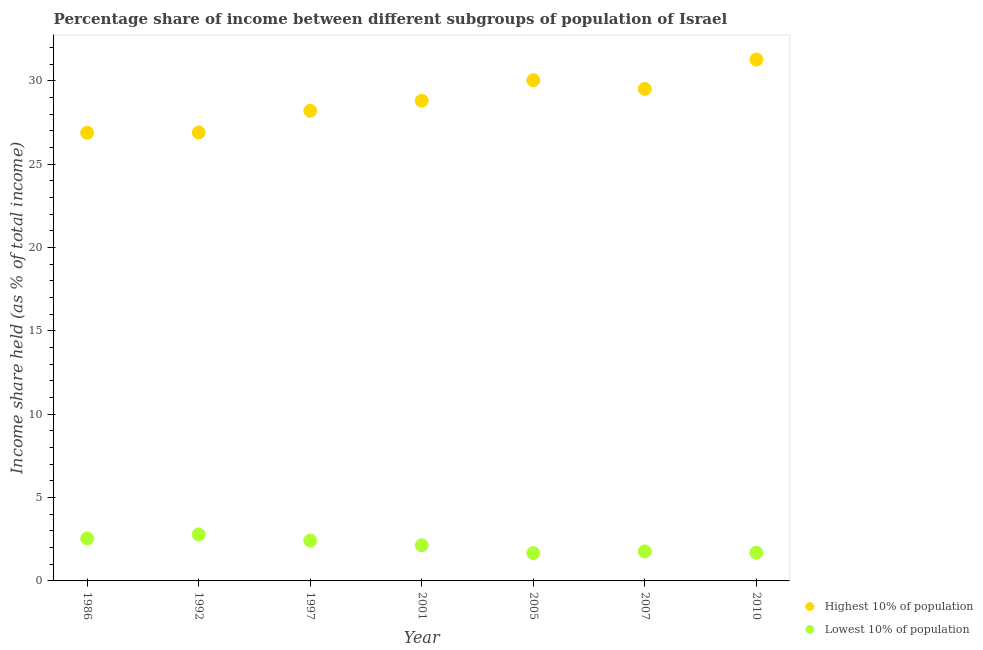Is the number of dotlines equal to the number of legend labels?
Keep it short and to the point. Yes. What is the income share held by lowest 10% of the population in 2001?
Your answer should be very brief. 2.14. Across all years, what is the maximum income share held by highest 10% of the population?
Your answer should be very brief. 31.27. Across all years, what is the minimum income share held by highest 10% of the population?
Make the answer very short. 26.88. In which year was the income share held by lowest 10% of the population maximum?
Your answer should be compact. 1992. What is the total income share held by highest 10% of the population in the graph?
Offer a terse response. 201.59. What is the difference between the income share held by lowest 10% of the population in 1997 and that in 2001?
Offer a terse response. 0.28. What is the difference between the income share held by lowest 10% of the population in 2010 and the income share held by highest 10% of the population in 1986?
Provide a short and direct response. -25.19. What is the average income share held by lowest 10% of the population per year?
Your response must be concise. 2.15. In the year 1997, what is the difference between the income share held by highest 10% of the population and income share held by lowest 10% of the population?
Offer a very short reply. 25.78. In how many years, is the income share held by lowest 10% of the population greater than 19 %?
Keep it short and to the point. 0. What is the ratio of the income share held by highest 10% of the population in 1986 to that in 2007?
Ensure brevity in your answer.  0.91. Is the income share held by lowest 10% of the population in 1992 less than that in 2007?
Ensure brevity in your answer.  No. What is the difference between the highest and the second highest income share held by lowest 10% of the population?
Your response must be concise. 0.24. What is the difference between the highest and the lowest income share held by highest 10% of the population?
Keep it short and to the point. 4.39. In how many years, is the income share held by lowest 10% of the population greater than the average income share held by lowest 10% of the population taken over all years?
Make the answer very short. 3. Is the income share held by highest 10% of the population strictly greater than the income share held by lowest 10% of the population over the years?
Keep it short and to the point. Yes. How many years are there in the graph?
Your answer should be compact. 7. What is the difference between two consecutive major ticks on the Y-axis?
Offer a very short reply. 5. Are the values on the major ticks of Y-axis written in scientific E-notation?
Give a very brief answer. No. Does the graph contain grids?
Give a very brief answer. No. Where does the legend appear in the graph?
Your answer should be very brief. Bottom right. How are the legend labels stacked?
Offer a terse response. Vertical. What is the title of the graph?
Provide a succinct answer. Percentage share of income between different subgroups of population of Israel. What is the label or title of the X-axis?
Offer a terse response. Year. What is the label or title of the Y-axis?
Provide a short and direct response. Income share held (as % of total income). What is the Income share held (as % of total income) of Highest 10% of population in 1986?
Offer a very short reply. 26.88. What is the Income share held (as % of total income) in Lowest 10% of population in 1986?
Provide a short and direct response. 2.55. What is the Income share held (as % of total income) in Highest 10% of population in 1992?
Your answer should be very brief. 26.9. What is the Income share held (as % of total income) in Lowest 10% of population in 1992?
Ensure brevity in your answer.  2.79. What is the Income share held (as % of total income) in Highest 10% of population in 1997?
Your response must be concise. 28.2. What is the Income share held (as % of total income) of Lowest 10% of population in 1997?
Your response must be concise. 2.42. What is the Income share held (as % of total income) in Highest 10% of population in 2001?
Your answer should be compact. 28.8. What is the Income share held (as % of total income) of Lowest 10% of population in 2001?
Offer a very short reply. 2.14. What is the Income share held (as % of total income) in Highest 10% of population in 2005?
Provide a succinct answer. 30.03. What is the Income share held (as % of total income) in Lowest 10% of population in 2005?
Provide a succinct answer. 1.67. What is the Income share held (as % of total income) in Highest 10% of population in 2007?
Offer a terse response. 29.51. What is the Income share held (as % of total income) of Lowest 10% of population in 2007?
Your response must be concise. 1.77. What is the Income share held (as % of total income) in Highest 10% of population in 2010?
Provide a succinct answer. 31.27. What is the Income share held (as % of total income) of Lowest 10% of population in 2010?
Give a very brief answer. 1.69. Across all years, what is the maximum Income share held (as % of total income) of Highest 10% of population?
Your response must be concise. 31.27. Across all years, what is the maximum Income share held (as % of total income) in Lowest 10% of population?
Make the answer very short. 2.79. Across all years, what is the minimum Income share held (as % of total income) of Highest 10% of population?
Make the answer very short. 26.88. Across all years, what is the minimum Income share held (as % of total income) of Lowest 10% of population?
Provide a short and direct response. 1.67. What is the total Income share held (as % of total income) of Highest 10% of population in the graph?
Offer a terse response. 201.59. What is the total Income share held (as % of total income) in Lowest 10% of population in the graph?
Keep it short and to the point. 15.03. What is the difference between the Income share held (as % of total income) in Highest 10% of population in 1986 and that in 1992?
Your answer should be very brief. -0.02. What is the difference between the Income share held (as % of total income) in Lowest 10% of population in 1986 and that in 1992?
Ensure brevity in your answer.  -0.24. What is the difference between the Income share held (as % of total income) in Highest 10% of population in 1986 and that in 1997?
Offer a very short reply. -1.32. What is the difference between the Income share held (as % of total income) in Lowest 10% of population in 1986 and that in 1997?
Provide a short and direct response. 0.13. What is the difference between the Income share held (as % of total income) of Highest 10% of population in 1986 and that in 2001?
Make the answer very short. -1.92. What is the difference between the Income share held (as % of total income) in Lowest 10% of population in 1986 and that in 2001?
Your answer should be very brief. 0.41. What is the difference between the Income share held (as % of total income) of Highest 10% of population in 1986 and that in 2005?
Keep it short and to the point. -3.15. What is the difference between the Income share held (as % of total income) of Lowest 10% of population in 1986 and that in 2005?
Keep it short and to the point. 0.88. What is the difference between the Income share held (as % of total income) in Highest 10% of population in 1986 and that in 2007?
Give a very brief answer. -2.63. What is the difference between the Income share held (as % of total income) of Lowest 10% of population in 1986 and that in 2007?
Offer a very short reply. 0.78. What is the difference between the Income share held (as % of total income) in Highest 10% of population in 1986 and that in 2010?
Give a very brief answer. -4.39. What is the difference between the Income share held (as % of total income) in Lowest 10% of population in 1986 and that in 2010?
Your answer should be very brief. 0.86. What is the difference between the Income share held (as % of total income) of Highest 10% of population in 1992 and that in 1997?
Your answer should be compact. -1.3. What is the difference between the Income share held (as % of total income) of Lowest 10% of population in 1992 and that in 1997?
Your answer should be very brief. 0.37. What is the difference between the Income share held (as % of total income) in Lowest 10% of population in 1992 and that in 2001?
Offer a very short reply. 0.65. What is the difference between the Income share held (as % of total income) in Highest 10% of population in 1992 and that in 2005?
Keep it short and to the point. -3.13. What is the difference between the Income share held (as % of total income) in Lowest 10% of population in 1992 and that in 2005?
Your answer should be compact. 1.12. What is the difference between the Income share held (as % of total income) of Highest 10% of population in 1992 and that in 2007?
Make the answer very short. -2.61. What is the difference between the Income share held (as % of total income) in Lowest 10% of population in 1992 and that in 2007?
Your response must be concise. 1.02. What is the difference between the Income share held (as % of total income) in Highest 10% of population in 1992 and that in 2010?
Give a very brief answer. -4.37. What is the difference between the Income share held (as % of total income) of Highest 10% of population in 1997 and that in 2001?
Ensure brevity in your answer.  -0.6. What is the difference between the Income share held (as % of total income) of Lowest 10% of population in 1997 and that in 2001?
Give a very brief answer. 0.28. What is the difference between the Income share held (as % of total income) of Highest 10% of population in 1997 and that in 2005?
Keep it short and to the point. -1.83. What is the difference between the Income share held (as % of total income) in Highest 10% of population in 1997 and that in 2007?
Your response must be concise. -1.31. What is the difference between the Income share held (as % of total income) of Lowest 10% of population in 1997 and that in 2007?
Provide a succinct answer. 0.65. What is the difference between the Income share held (as % of total income) of Highest 10% of population in 1997 and that in 2010?
Provide a succinct answer. -3.07. What is the difference between the Income share held (as % of total income) of Lowest 10% of population in 1997 and that in 2010?
Ensure brevity in your answer.  0.73. What is the difference between the Income share held (as % of total income) in Highest 10% of population in 2001 and that in 2005?
Ensure brevity in your answer.  -1.23. What is the difference between the Income share held (as % of total income) in Lowest 10% of population in 2001 and that in 2005?
Keep it short and to the point. 0.47. What is the difference between the Income share held (as % of total income) of Highest 10% of population in 2001 and that in 2007?
Provide a succinct answer. -0.71. What is the difference between the Income share held (as % of total income) of Lowest 10% of population in 2001 and that in 2007?
Your answer should be compact. 0.37. What is the difference between the Income share held (as % of total income) of Highest 10% of population in 2001 and that in 2010?
Ensure brevity in your answer.  -2.47. What is the difference between the Income share held (as % of total income) of Lowest 10% of population in 2001 and that in 2010?
Keep it short and to the point. 0.45. What is the difference between the Income share held (as % of total income) of Highest 10% of population in 2005 and that in 2007?
Keep it short and to the point. 0.52. What is the difference between the Income share held (as % of total income) in Lowest 10% of population in 2005 and that in 2007?
Provide a succinct answer. -0.1. What is the difference between the Income share held (as % of total income) of Highest 10% of population in 2005 and that in 2010?
Your response must be concise. -1.24. What is the difference between the Income share held (as % of total income) of Lowest 10% of population in 2005 and that in 2010?
Provide a succinct answer. -0.02. What is the difference between the Income share held (as % of total income) in Highest 10% of population in 2007 and that in 2010?
Offer a very short reply. -1.76. What is the difference between the Income share held (as % of total income) in Highest 10% of population in 1986 and the Income share held (as % of total income) in Lowest 10% of population in 1992?
Your answer should be very brief. 24.09. What is the difference between the Income share held (as % of total income) in Highest 10% of population in 1986 and the Income share held (as % of total income) in Lowest 10% of population in 1997?
Ensure brevity in your answer.  24.46. What is the difference between the Income share held (as % of total income) in Highest 10% of population in 1986 and the Income share held (as % of total income) in Lowest 10% of population in 2001?
Provide a short and direct response. 24.74. What is the difference between the Income share held (as % of total income) of Highest 10% of population in 1986 and the Income share held (as % of total income) of Lowest 10% of population in 2005?
Your answer should be very brief. 25.21. What is the difference between the Income share held (as % of total income) of Highest 10% of population in 1986 and the Income share held (as % of total income) of Lowest 10% of population in 2007?
Provide a succinct answer. 25.11. What is the difference between the Income share held (as % of total income) in Highest 10% of population in 1986 and the Income share held (as % of total income) in Lowest 10% of population in 2010?
Your answer should be compact. 25.19. What is the difference between the Income share held (as % of total income) in Highest 10% of population in 1992 and the Income share held (as % of total income) in Lowest 10% of population in 1997?
Keep it short and to the point. 24.48. What is the difference between the Income share held (as % of total income) in Highest 10% of population in 1992 and the Income share held (as % of total income) in Lowest 10% of population in 2001?
Ensure brevity in your answer.  24.76. What is the difference between the Income share held (as % of total income) of Highest 10% of population in 1992 and the Income share held (as % of total income) of Lowest 10% of population in 2005?
Keep it short and to the point. 25.23. What is the difference between the Income share held (as % of total income) of Highest 10% of population in 1992 and the Income share held (as % of total income) of Lowest 10% of population in 2007?
Provide a succinct answer. 25.13. What is the difference between the Income share held (as % of total income) in Highest 10% of population in 1992 and the Income share held (as % of total income) in Lowest 10% of population in 2010?
Give a very brief answer. 25.21. What is the difference between the Income share held (as % of total income) in Highest 10% of population in 1997 and the Income share held (as % of total income) in Lowest 10% of population in 2001?
Your answer should be compact. 26.06. What is the difference between the Income share held (as % of total income) of Highest 10% of population in 1997 and the Income share held (as % of total income) of Lowest 10% of population in 2005?
Provide a short and direct response. 26.53. What is the difference between the Income share held (as % of total income) of Highest 10% of population in 1997 and the Income share held (as % of total income) of Lowest 10% of population in 2007?
Offer a very short reply. 26.43. What is the difference between the Income share held (as % of total income) of Highest 10% of population in 1997 and the Income share held (as % of total income) of Lowest 10% of population in 2010?
Ensure brevity in your answer.  26.51. What is the difference between the Income share held (as % of total income) in Highest 10% of population in 2001 and the Income share held (as % of total income) in Lowest 10% of population in 2005?
Provide a short and direct response. 27.13. What is the difference between the Income share held (as % of total income) of Highest 10% of population in 2001 and the Income share held (as % of total income) of Lowest 10% of population in 2007?
Provide a short and direct response. 27.03. What is the difference between the Income share held (as % of total income) in Highest 10% of population in 2001 and the Income share held (as % of total income) in Lowest 10% of population in 2010?
Give a very brief answer. 27.11. What is the difference between the Income share held (as % of total income) in Highest 10% of population in 2005 and the Income share held (as % of total income) in Lowest 10% of population in 2007?
Offer a terse response. 28.26. What is the difference between the Income share held (as % of total income) of Highest 10% of population in 2005 and the Income share held (as % of total income) of Lowest 10% of population in 2010?
Give a very brief answer. 28.34. What is the difference between the Income share held (as % of total income) of Highest 10% of population in 2007 and the Income share held (as % of total income) of Lowest 10% of population in 2010?
Provide a succinct answer. 27.82. What is the average Income share held (as % of total income) in Highest 10% of population per year?
Your answer should be compact. 28.8. What is the average Income share held (as % of total income) of Lowest 10% of population per year?
Offer a terse response. 2.15. In the year 1986, what is the difference between the Income share held (as % of total income) of Highest 10% of population and Income share held (as % of total income) of Lowest 10% of population?
Make the answer very short. 24.33. In the year 1992, what is the difference between the Income share held (as % of total income) of Highest 10% of population and Income share held (as % of total income) of Lowest 10% of population?
Ensure brevity in your answer.  24.11. In the year 1997, what is the difference between the Income share held (as % of total income) in Highest 10% of population and Income share held (as % of total income) in Lowest 10% of population?
Provide a succinct answer. 25.78. In the year 2001, what is the difference between the Income share held (as % of total income) of Highest 10% of population and Income share held (as % of total income) of Lowest 10% of population?
Ensure brevity in your answer.  26.66. In the year 2005, what is the difference between the Income share held (as % of total income) in Highest 10% of population and Income share held (as % of total income) in Lowest 10% of population?
Your answer should be very brief. 28.36. In the year 2007, what is the difference between the Income share held (as % of total income) in Highest 10% of population and Income share held (as % of total income) in Lowest 10% of population?
Your answer should be very brief. 27.74. In the year 2010, what is the difference between the Income share held (as % of total income) of Highest 10% of population and Income share held (as % of total income) of Lowest 10% of population?
Your answer should be very brief. 29.58. What is the ratio of the Income share held (as % of total income) in Lowest 10% of population in 1986 to that in 1992?
Offer a very short reply. 0.91. What is the ratio of the Income share held (as % of total income) of Highest 10% of population in 1986 to that in 1997?
Your answer should be very brief. 0.95. What is the ratio of the Income share held (as % of total income) of Lowest 10% of population in 1986 to that in 1997?
Your response must be concise. 1.05. What is the ratio of the Income share held (as % of total income) of Highest 10% of population in 1986 to that in 2001?
Keep it short and to the point. 0.93. What is the ratio of the Income share held (as % of total income) of Lowest 10% of population in 1986 to that in 2001?
Your answer should be very brief. 1.19. What is the ratio of the Income share held (as % of total income) in Highest 10% of population in 1986 to that in 2005?
Give a very brief answer. 0.9. What is the ratio of the Income share held (as % of total income) of Lowest 10% of population in 1986 to that in 2005?
Your response must be concise. 1.53. What is the ratio of the Income share held (as % of total income) of Highest 10% of population in 1986 to that in 2007?
Provide a short and direct response. 0.91. What is the ratio of the Income share held (as % of total income) of Lowest 10% of population in 1986 to that in 2007?
Keep it short and to the point. 1.44. What is the ratio of the Income share held (as % of total income) of Highest 10% of population in 1986 to that in 2010?
Give a very brief answer. 0.86. What is the ratio of the Income share held (as % of total income) of Lowest 10% of population in 1986 to that in 2010?
Your response must be concise. 1.51. What is the ratio of the Income share held (as % of total income) of Highest 10% of population in 1992 to that in 1997?
Ensure brevity in your answer.  0.95. What is the ratio of the Income share held (as % of total income) in Lowest 10% of population in 1992 to that in 1997?
Keep it short and to the point. 1.15. What is the ratio of the Income share held (as % of total income) in Highest 10% of population in 1992 to that in 2001?
Make the answer very short. 0.93. What is the ratio of the Income share held (as % of total income) of Lowest 10% of population in 1992 to that in 2001?
Offer a very short reply. 1.3. What is the ratio of the Income share held (as % of total income) of Highest 10% of population in 1992 to that in 2005?
Provide a succinct answer. 0.9. What is the ratio of the Income share held (as % of total income) of Lowest 10% of population in 1992 to that in 2005?
Give a very brief answer. 1.67. What is the ratio of the Income share held (as % of total income) in Highest 10% of population in 1992 to that in 2007?
Offer a very short reply. 0.91. What is the ratio of the Income share held (as % of total income) of Lowest 10% of population in 1992 to that in 2007?
Your answer should be very brief. 1.58. What is the ratio of the Income share held (as % of total income) in Highest 10% of population in 1992 to that in 2010?
Offer a terse response. 0.86. What is the ratio of the Income share held (as % of total income) in Lowest 10% of population in 1992 to that in 2010?
Your answer should be very brief. 1.65. What is the ratio of the Income share held (as % of total income) in Highest 10% of population in 1997 to that in 2001?
Offer a very short reply. 0.98. What is the ratio of the Income share held (as % of total income) of Lowest 10% of population in 1997 to that in 2001?
Your response must be concise. 1.13. What is the ratio of the Income share held (as % of total income) of Highest 10% of population in 1997 to that in 2005?
Your answer should be compact. 0.94. What is the ratio of the Income share held (as % of total income) of Lowest 10% of population in 1997 to that in 2005?
Keep it short and to the point. 1.45. What is the ratio of the Income share held (as % of total income) in Highest 10% of population in 1997 to that in 2007?
Offer a terse response. 0.96. What is the ratio of the Income share held (as % of total income) of Lowest 10% of population in 1997 to that in 2007?
Make the answer very short. 1.37. What is the ratio of the Income share held (as % of total income) in Highest 10% of population in 1997 to that in 2010?
Ensure brevity in your answer.  0.9. What is the ratio of the Income share held (as % of total income) in Lowest 10% of population in 1997 to that in 2010?
Offer a very short reply. 1.43. What is the ratio of the Income share held (as % of total income) in Lowest 10% of population in 2001 to that in 2005?
Ensure brevity in your answer.  1.28. What is the ratio of the Income share held (as % of total income) in Highest 10% of population in 2001 to that in 2007?
Keep it short and to the point. 0.98. What is the ratio of the Income share held (as % of total income) in Lowest 10% of population in 2001 to that in 2007?
Your answer should be very brief. 1.21. What is the ratio of the Income share held (as % of total income) of Highest 10% of population in 2001 to that in 2010?
Make the answer very short. 0.92. What is the ratio of the Income share held (as % of total income) in Lowest 10% of population in 2001 to that in 2010?
Provide a short and direct response. 1.27. What is the ratio of the Income share held (as % of total income) of Highest 10% of population in 2005 to that in 2007?
Give a very brief answer. 1.02. What is the ratio of the Income share held (as % of total income) in Lowest 10% of population in 2005 to that in 2007?
Your answer should be very brief. 0.94. What is the ratio of the Income share held (as % of total income) in Highest 10% of population in 2005 to that in 2010?
Give a very brief answer. 0.96. What is the ratio of the Income share held (as % of total income) of Lowest 10% of population in 2005 to that in 2010?
Your answer should be compact. 0.99. What is the ratio of the Income share held (as % of total income) of Highest 10% of population in 2007 to that in 2010?
Give a very brief answer. 0.94. What is the ratio of the Income share held (as % of total income) of Lowest 10% of population in 2007 to that in 2010?
Keep it short and to the point. 1.05. What is the difference between the highest and the second highest Income share held (as % of total income) of Highest 10% of population?
Make the answer very short. 1.24. What is the difference between the highest and the second highest Income share held (as % of total income) of Lowest 10% of population?
Your response must be concise. 0.24. What is the difference between the highest and the lowest Income share held (as % of total income) of Highest 10% of population?
Your answer should be very brief. 4.39. What is the difference between the highest and the lowest Income share held (as % of total income) in Lowest 10% of population?
Give a very brief answer. 1.12. 